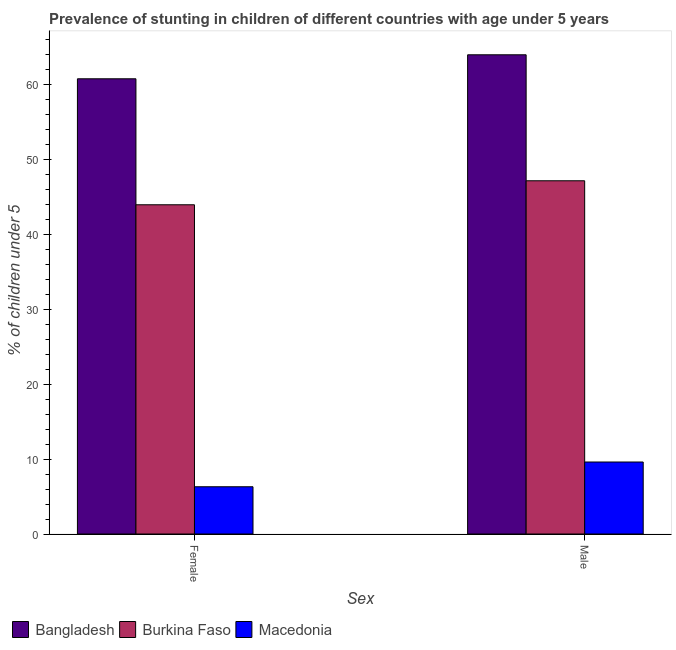How many bars are there on the 2nd tick from the right?
Provide a succinct answer. 3. What is the label of the 2nd group of bars from the left?
Your answer should be compact. Male. What is the percentage of stunted female children in Macedonia?
Your answer should be very brief. 6.3. Across all countries, what is the maximum percentage of stunted male children?
Make the answer very short. 63.9. Across all countries, what is the minimum percentage of stunted male children?
Keep it short and to the point. 9.6. In which country was the percentage of stunted male children maximum?
Give a very brief answer. Bangladesh. In which country was the percentage of stunted female children minimum?
Offer a terse response. Macedonia. What is the total percentage of stunted female children in the graph?
Give a very brief answer. 110.9. What is the difference between the percentage of stunted female children in Bangladesh and that in Macedonia?
Offer a very short reply. 54.4. What is the difference between the percentage of stunted female children in Macedonia and the percentage of stunted male children in Bangladesh?
Provide a short and direct response. -57.6. What is the average percentage of stunted male children per country?
Make the answer very short. 40.2. What is the difference between the percentage of stunted male children and percentage of stunted female children in Bangladesh?
Your answer should be very brief. 3.2. What is the ratio of the percentage of stunted female children in Burkina Faso to that in Bangladesh?
Your response must be concise. 0.72. Is the percentage of stunted female children in Macedonia less than that in Bangladesh?
Give a very brief answer. Yes. In how many countries, is the percentage of stunted female children greater than the average percentage of stunted female children taken over all countries?
Provide a short and direct response. 2. What does the 2nd bar from the right in Male represents?
Provide a succinct answer. Burkina Faso. How many bars are there?
Keep it short and to the point. 6. Are all the bars in the graph horizontal?
Make the answer very short. No. How many countries are there in the graph?
Keep it short and to the point. 3. Does the graph contain grids?
Offer a terse response. No. Where does the legend appear in the graph?
Your answer should be very brief. Bottom left. How many legend labels are there?
Give a very brief answer. 3. How are the legend labels stacked?
Keep it short and to the point. Horizontal. What is the title of the graph?
Make the answer very short. Prevalence of stunting in children of different countries with age under 5 years. What is the label or title of the X-axis?
Give a very brief answer. Sex. What is the label or title of the Y-axis?
Provide a short and direct response.  % of children under 5. What is the  % of children under 5 of Bangladesh in Female?
Ensure brevity in your answer.  60.7. What is the  % of children under 5 in Burkina Faso in Female?
Offer a terse response. 43.9. What is the  % of children under 5 of Macedonia in Female?
Provide a succinct answer. 6.3. What is the  % of children under 5 of Bangladesh in Male?
Offer a very short reply. 63.9. What is the  % of children under 5 of Burkina Faso in Male?
Provide a short and direct response. 47.1. What is the  % of children under 5 of Macedonia in Male?
Make the answer very short. 9.6. Across all Sex, what is the maximum  % of children under 5 of Bangladesh?
Give a very brief answer. 63.9. Across all Sex, what is the maximum  % of children under 5 of Burkina Faso?
Offer a terse response. 47.1. Across all Sex, what is the maximum  % of children under 5 in Macedonia?
Offer a terse response. 9.6. Across all Sex, what is the minimum  % of children under 5 of Bangladesh?
Make the answer very short. 60.7. Across all Sex, what is the minimum  % of children under 5 in Burkina Faso?
Provide a succinct answer. 43.9. Across all Sex, what is the minimum  % of children under 5 of Macedonia?
Your answer should be compact. 6.3. What is the total  % of children under 5 of Bangladesh in the graph?
Provide a succinct answer. 124.6. What is the total  % of children under 5 in Burkina Faso in the graph?
Your answer should be very brief. 91. What is the total  % of children under 5 of Macedonia in the graph?
Offer a terse response. 15.9. What is the difference between the  % of children under 5 in Bangladesh in Female and that in Male?
Ensure brevity in your answer.  -3.2. What is the difference between the  % of children under 5 of Macedonia in Female and that in Male?
Your response must be concise. -3.3. What is the difference between the  % of children under 5 of Bangladesh in Female and the  % of children under 5 of Macedonia in Male?
Provide a short and direct response. 51.1. What is the difference between the  % of children under 5 in Burkina Faso in Female and the  % of children under 5 in Macedonia in Male?
Provide a short and direct response. 34.3. What is the average  % of children under 5 of Bangladesh per Sex?
Provide a succinct answer. 62.3. What is the average  % of children under 5 in Burkina Faso per Sex?
Offer a very short reply. 45.5. What is the average  % of children under 5 of Macedonia per Sex?
Keep it short and to the point. 7.95. What is the difference between the  % of children under 5 in Bangladesh and  % of children under 5 in Macedonia in Female?
Provide a succinct answer. 54.4. What is the difference between the  % of children under 5 of Burkina Faso and  % of children under 5 of Macedonia in Female?
Offer a terse response. 37.6. What is the difference between the  % of children under 5 of Bangladesh and  % of children under 5 of Macedonia in Male?
Offer a very short reply. 54.3. What is the difference between the  % of children under 5 in Burkina Faso and  % of children under 5 in Macedonia in Male?
Your response must be concise. 37.5. What is the ratio of the  % of children under 5 of Bangladesh in Female to that in Male?
Provide a short and direct response. 0.95. What is the ratio of the  % of children under 5 of Burkina Faso in Female to that in Male?
Your answer should be compact. 0.93. What is the ratio of the  % of children under 5 of Macedonia in Female to that in Male?
Provide a succinct answer. 0.66. What is the difference between the highest and the second highest  % of children under 5 in Bangladesh?
Give a very brief answer. 3.2. What is the difference between the highest and the second highest  % of children under 5 of Burkina Faso?
Ensure brevity in your answer.  3.2. What is the difference between the highest and the second highest  % of children under 5 in Macedonia?
Keep it short and to the point. 3.3. What is the difference between the highest and the lowest  % of children under 5 in Bangladesh?
Offer a very short reply. 3.2. 